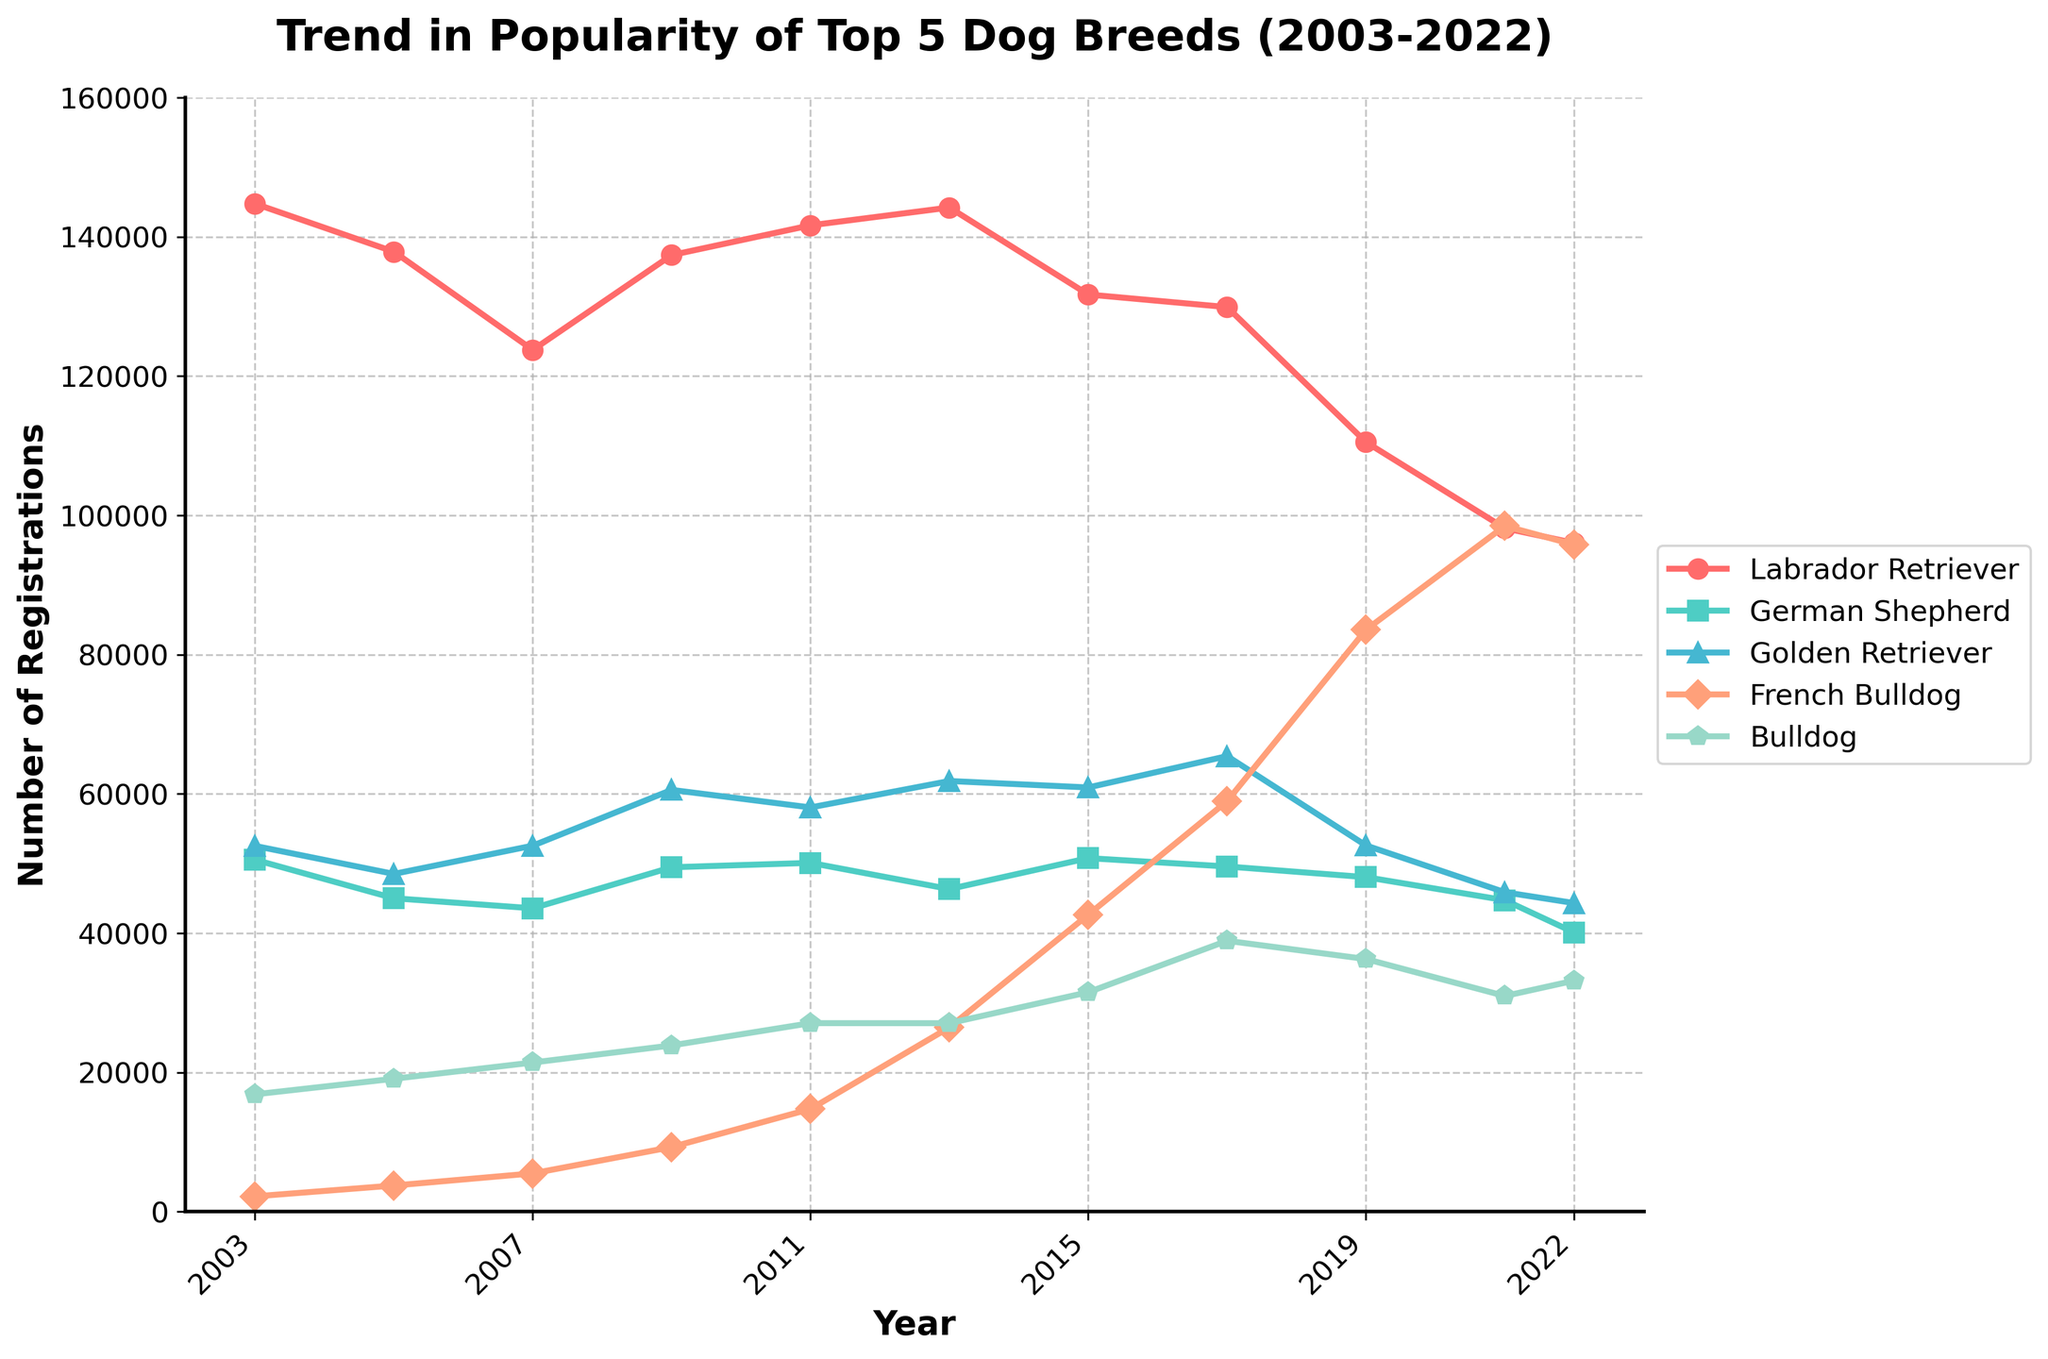What's the trend in popularity for Labrador Retrievers from 2003 to 2022? Labrador Retriever numbers peaked around 2003 with approximately 144,759 registrations and then showed a generally declining trend down to about 96,031 by 2022.
Answer: Declining Trend Which breed had the highest number of registrations in 2022? In 2022, the breed with the highest number of registrations was the French Bulldog, with approximately 95,783 registrations.
Answer: French Bulldog When comparing 2011 and 2021, which breed had the largest increase in the number of registrations? To find the breed with the largest increase, calculate the difference in registrations for each breed between 2011 and 2021. The French Bulldog increased from 14,749 in 2011 to 98,485 in 2021, which is the largest increment.
Answer: French Bulldog Which breed generally had the lowest number of registrations over the 20 years? By observing the trends, the French Bulldog had the lowest registrations initially from 2003 to 2013 before rising sharply afterward. However, throughout the entire period, the French Bulldog started lower than others.
Answer: French Bulldog Compare the trend in popularity between Golden Retriever and Bulldog from 2009 to 2022. Both Golden Retriever and Bulldog showed fluctuating trends, but while Golden Retriever registrations decreased slightly from 2009 to 2022 (from about 60,575 to 44,319), Bulldog's registrations generally increased from 23,881 to 33,184.
Answer: Golden Retriever: Decreasing, Bulldog: Increasing In which year did the German Shepherd have the highest number of registrations, and what was the approximate number? The German Shepherd had the highest number of registrations in 2011, with approximately 50,096 registrations.
Answer: 2011, 50,096 How did the popularity of French Bulldogs change from 2009 to 2019? The registrations for French Bulldogs increased drastically from about 9,281 in 2009 to approximately 83,574 in 2019.
Answer: Increased Significantly What was the most popular dog breed in 2017, and by how much did it beat the second most popular breed? In 2017, the Labrador Retriever was the most popular breed with about 129,913 registrations. The second most popular was the French Bulldog with about 58,961 registrations. The difference is approximately 70,952 registrations.
Answer: Labrador Retriever, ~70,952 What's the average number of registrations for Bulldogs over the years presented? To find the average number of registrations for Bulldogs, sum up their yearly registrations and divide by the number of years. (16,858 + 19,093 + 21,423 + 23,881 + 27,080 + 27,072 + 31,519 + 38,907 + 36,284 + 30,980 + 33,184) / 11 ≈ 27,037
Answer: 27,037 